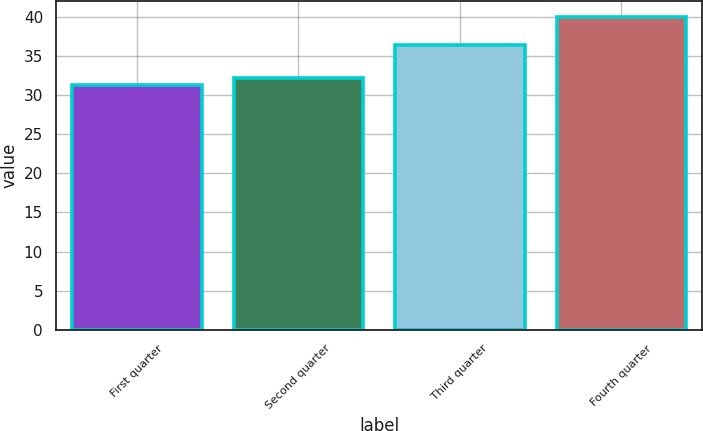Convert chart to OTSL. <chart><loc_0><loc_0><loc_500><loc_500><bar_chart><fcel>First quarter<fcel>Second quarter<fcel>Third quarter<fcel>Fourth quarter<nl><fcel>31.29<fcel>32.16<fcel>36.43<fcel>40<nl></chart> 